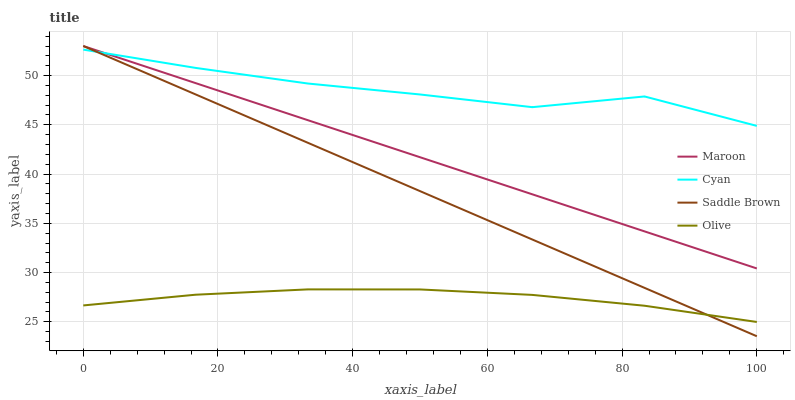Does Olive have the minimum area under the curve?
Answer yes or no. Yes. Does Cyan have the maximum area under the curve?
Answer yes or no. Yes. Does Saddle Brown have the minimum area under the curve?
Answer yes or no. No. Does Saddle Brown have the maximum area under the curve?
Answer yes or no. No. Is Saddle Brown the smoothest?
Answer yes or no. Yes. Is Cyan the roughest?
Answer yes or no. Yes. Is Cyan the smoothest?
Answer yes or no. No. Is Saddle Brown the roughest?
Answer yes or no. No. Does Saddle Brown have the lowest value?
Answer yes or no. Yes. Does Cyan have the lowest value?
Answer yes or no. No. Does Maroon have the highest value?
Answer yes or no. Yes. Does Cyan have the highest value?
Answer yes or no. No. Is Olive less than Cyan?
Answer yes or no. Yes. Is Maroon greater than Olive?
Answer yes or no. Yes. Does Maroon intersect Saddle Brown?
Answer yes or no. Yes. Is Maroon less than Saddle Brown?
Answer yes or no. No. Is Maroon greater than Saddle Brown?
Answer yes or no. No. Does Olive intersect Cyan?
Answer yes or no. No. 